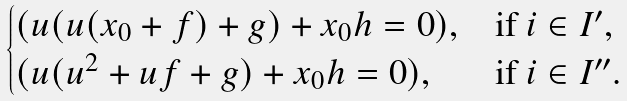Convert formula to latex. <formula><loc_0><loc_0><loc_500><loc_500>\begin{cases} ( u ( u ( x _ { 0 } + f ) + g ) + x _ { 0 } h = 0 ) , & \text {if } i \in I ^ { \prime } , \\ ( u ( u ^ { 2 } + u f + g ) + x _ { 0 } h = 0 ) , & \text {if } i \in I ^ { \prime \prime } . \end{cases}</formula> 